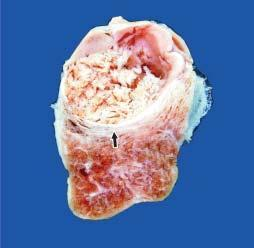does cut surface of the enlarged thyroid gland show a single nodule separated from the rest of thyroid parenchyma by incomplete fibrous septa?
Answer the question using a single word or phrase. Yes 